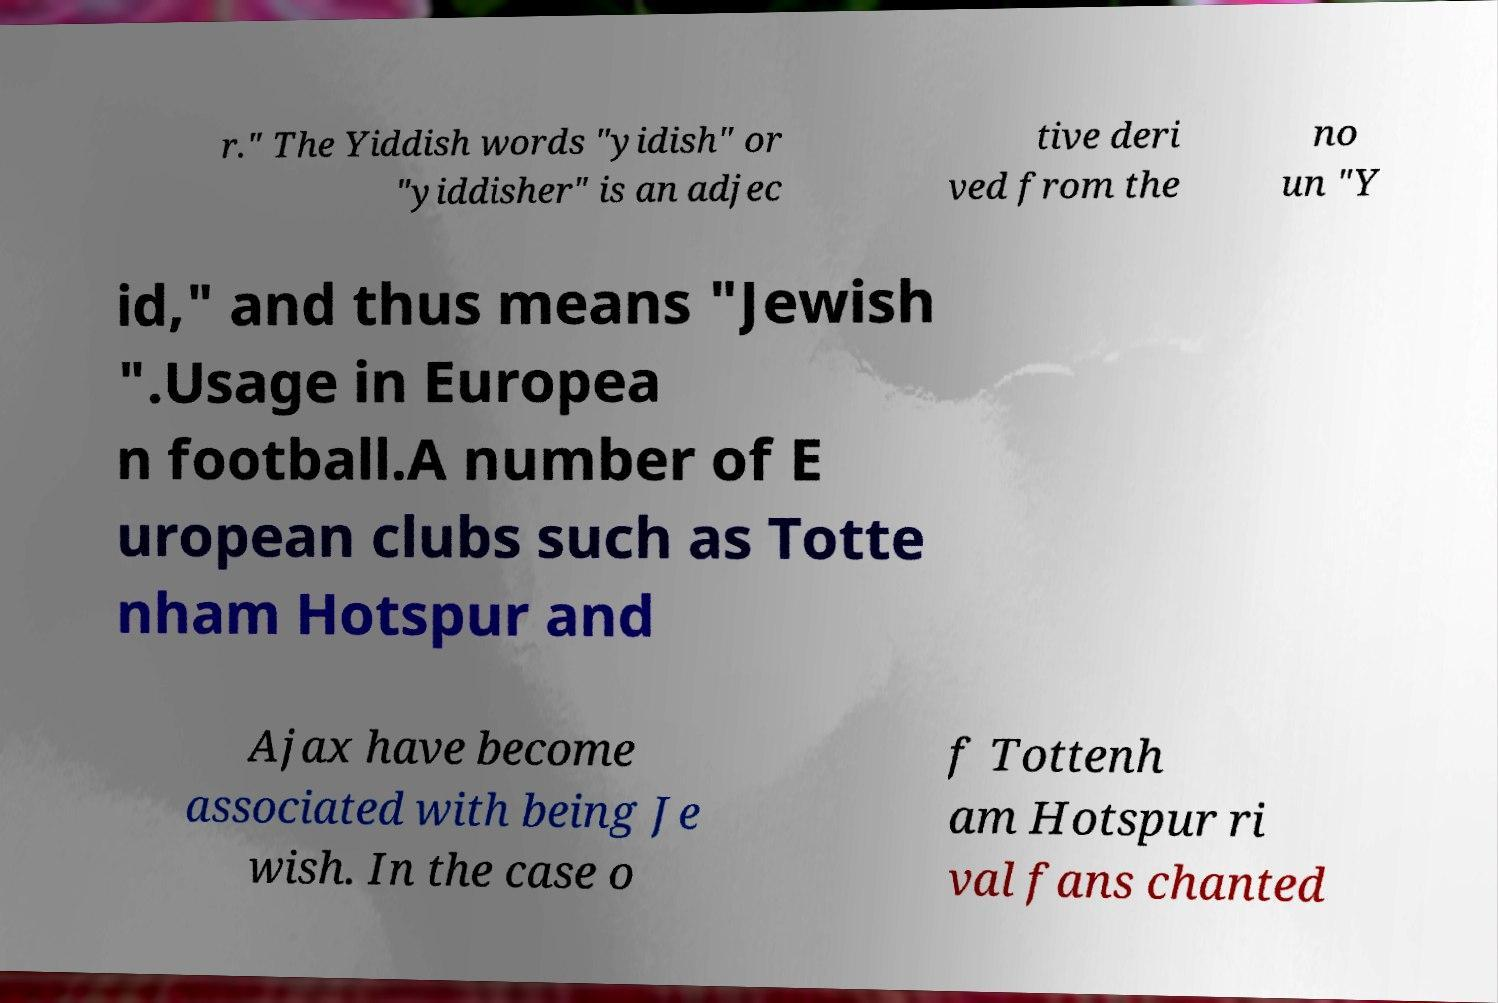Can you accurately transcribe the text from the provided image for me? r." The Yiddish words "yidish" or "yiddisher" is an adjec tive deri ved from the no un "Y id," and thus means "Jewish ".Usage in Europea n football.A number of E uropean clubs such as Totte nham Hotspur and Ajax have become associated with being Je wish. In the case o f Tottenh am Hotspur ri val fans chanted 